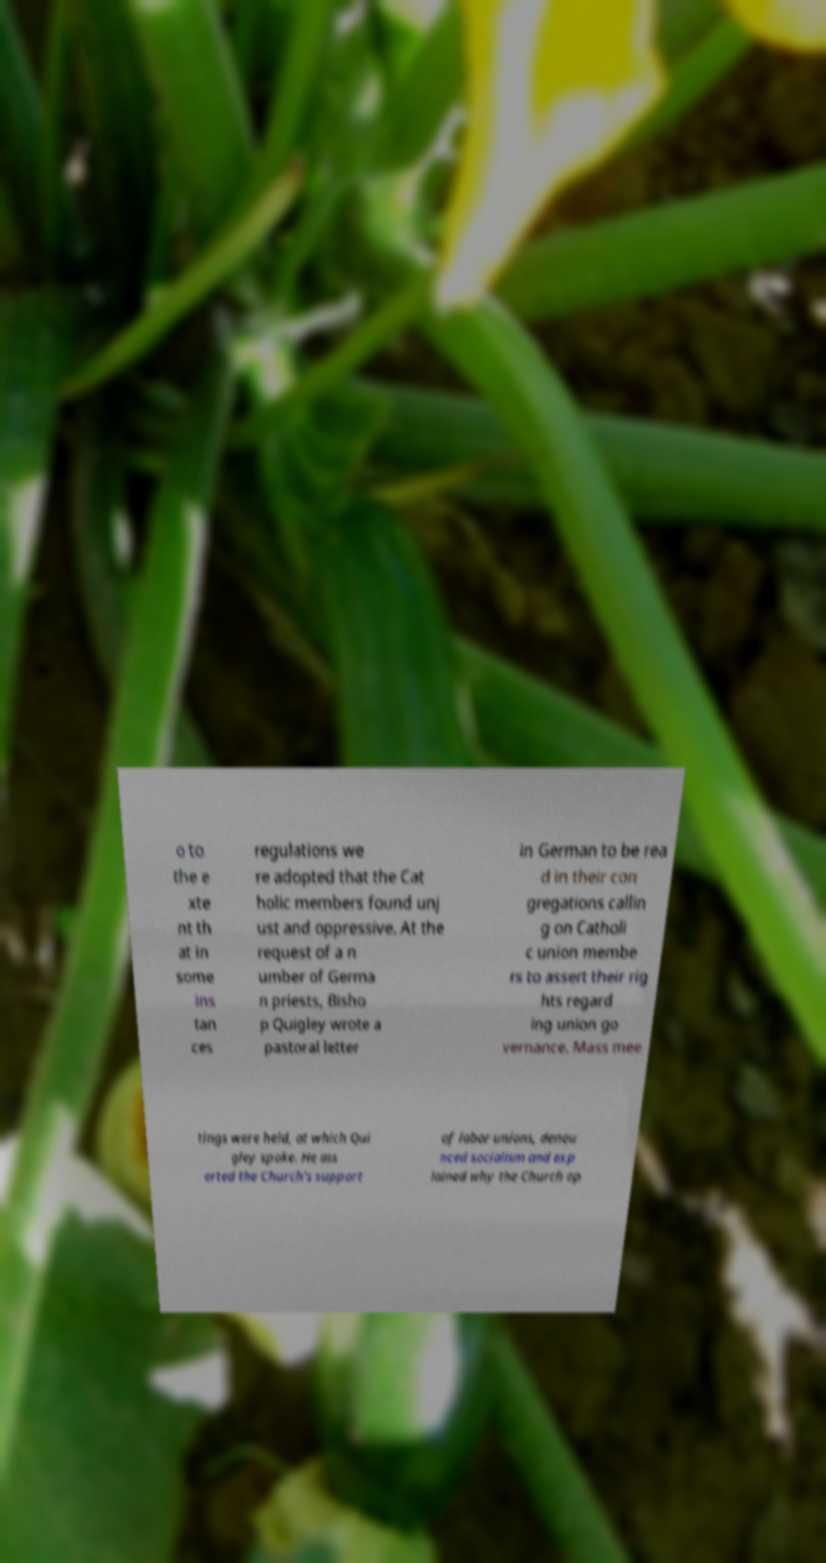Could you assist in decoding the text presented in this image and type it out clearly? o to the e xte nt th at in some ins tan ces regulations we re adopted that the Cat holic members found unj ust and oppressive. At the request of a n umber of Germa n priests, Bisho p Quigley wrote a pastoral letter in German to be rea d in their con gregations callin g on Catholi c union membe rs to assert their rig hts regard ing union go vernance. Mass mee tings were held, at which Qui gley spoke. He ass erted the Church's support of labor unions, denou nced socialism and exp lained why the Church op 